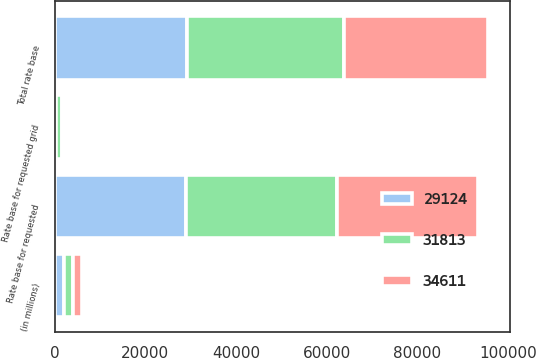Convert chart. <chart><loc_0><loc_0><loc_500><loc_500><stacked_bar_chart><ecel><fcel>(in millions)<fcel>Rate base for requested<fcel>Rate base for requested grid<fcel>Total rate base<nl><fcel>29124<fcel>2018<fcel>28860<fcel>264<fcel>29124<nl><fcel>34611<fcel>2019<fcel>31070<fcel>743<fcel>31813<nl><fcel>31813<fcel>2020<fcel>33332<fcel>1279<fcel>34611<nl></chart> 